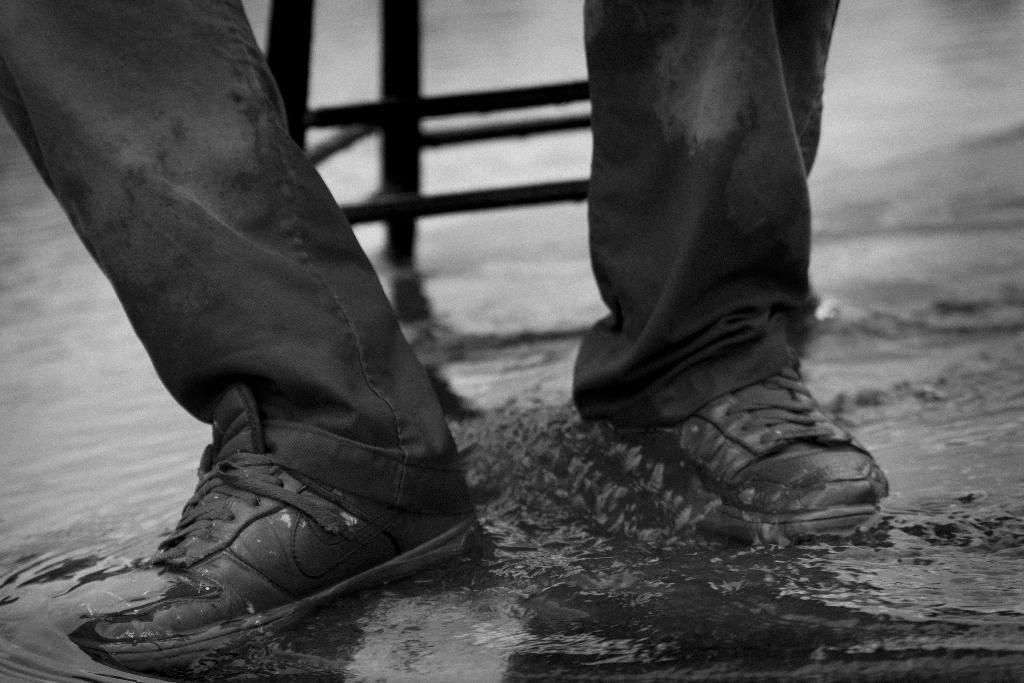What can be seen in the image that is not a part of a person? There is water visible in the image. What part of a person can be seen in the image? The legs of a person are visible in the image. What type of footwear is the person wearing? The person is wearing shoes. What type of education is the person receiving in the image? There is no indication of any educational activity in the image. 